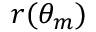Convert formula to latex. <formula><loc_0><loc_0><loc_500><loc_500>r ( \theta _ { m } )</formula> 